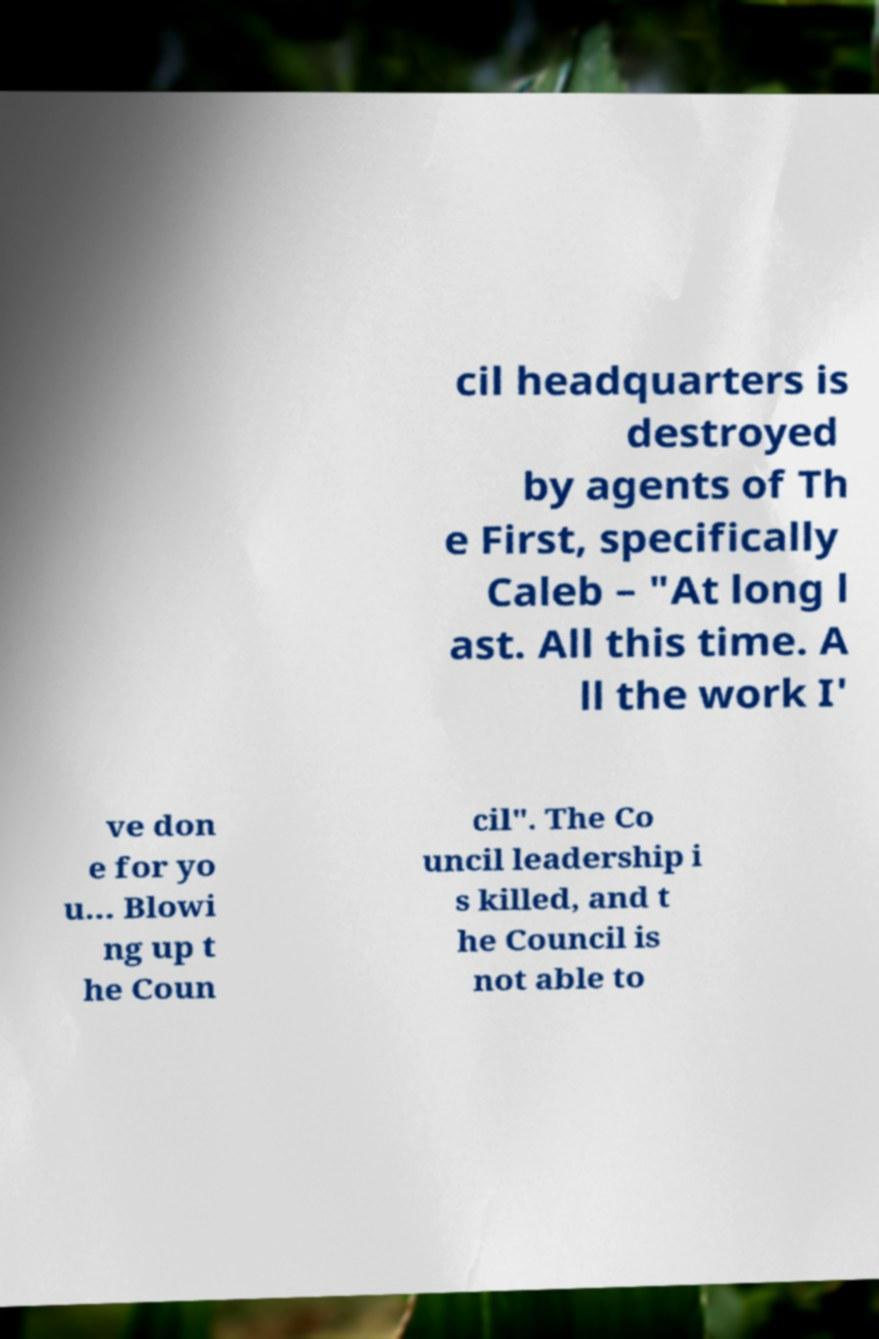Can you accurately transcribe the text from the provided image for me? cil headquarters is destroyed by agents of Th e First, specifically Caleb – "At long l ast. All this time. A ll the work I' ve don e for yo u... Blowi ng up t he Coun cil". The Co uncil leadership i s killed, and t he Council is not able to 